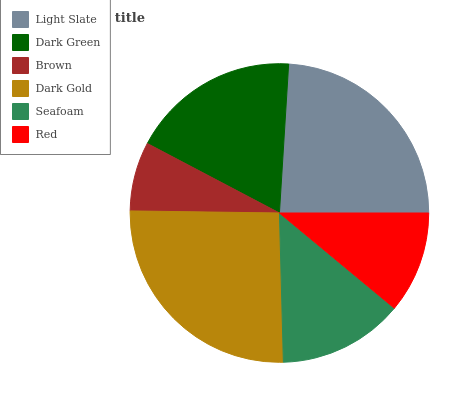Is Brown the minimum?
Answer yes or no. Yes. Is Dark Gold the maximum?
Answer yes or no. Yes. Is Dark Green the minimum?
Answer yes or no. No. Is Dark Green the maximum?
Answer yes or no. No. Is Light Slate greater than Dark Green?
Answer yes or no. Yes. Is Dark Green less than Light Slate?
Answer yes or no. Yes. Is Dark Green greater than Light Slate?
Answer yes or no. No. Is Light Slate less than Dark Green?
Answer yes or no. No. Is Dark Green the high median?
Answer yes or no. Yes. Is Seafoam the low median?
Answer yes or no. Yes. Is Red the high median?
Answer yes or no. No. Is Light Slate the low median?
Answer yes or no. No. 